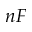Convert formula to latex. <formula><loc_0><loc_0><loc_500><loc_500>n F</formula> 